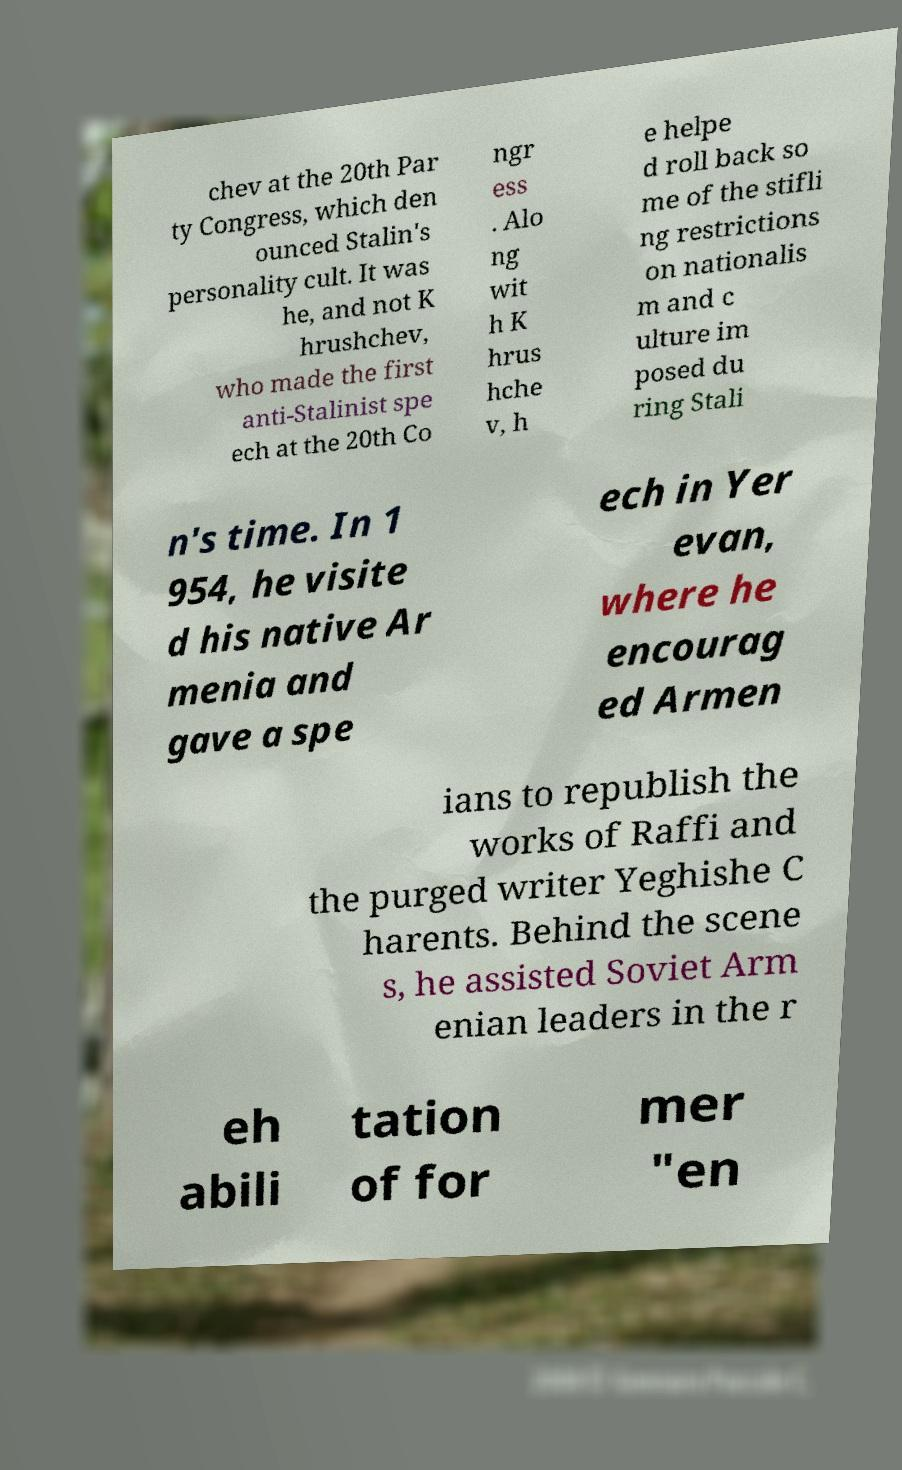There's text embedded in this image that I need extracted. Can you transcribe it verbatim? chev at the 20th Par ty Congress, which den ounced Stalin's personality cult. It was he, and not K hrushchev, who made the first anti-Stalinist spe ech at the 20th Co ngr ess . Alo ng wit h K hrus hche v, h e helpe d roll back so me of the stifli ng restrictions on nationalis m and c ulture im posed du ring Stali n's time. In 1 954, he visite d his native Ar menia and gave a spe ech in Yer evan, where he encourag ed Armen ians to republish the works of Raffi and the purged writer Yeghishe C harents. Behind the scene s, he assisted Soviet Arm enian leaders in the r eh abili tation of for mer "en 